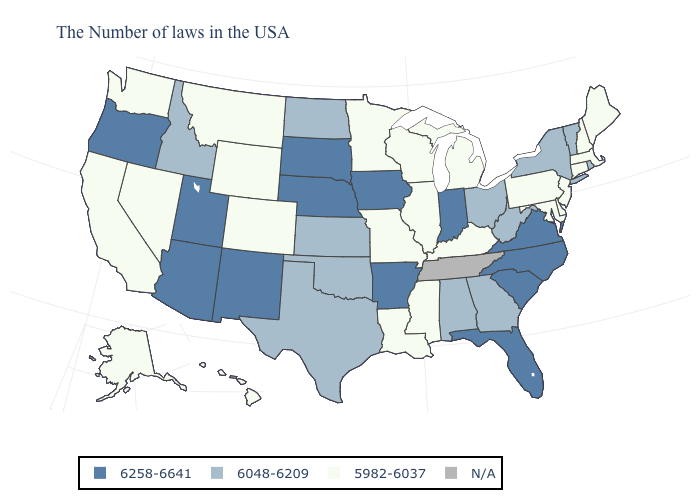Does the map have missing data?
Be succinct. Yes. Is the legend a continuous bar?
Write a very short answer. No. Name the states that have a value in the range 6048-6209?
Quick response, please. Rhode Island, Vermont, New York, West Virginia, Ohio, Georgia, Alabama, Kansas, Oklahoma, Texas, North Dakota, Idaho. What is the value of Nebraska?
Answer briefly. 6258-6641. Name the states that have a value in the range 5982-6037?
Give a very brief answer. Maine, Massachusetts, New Hampshire, Connecticut, New Jersey, Delaware, Maryland, Pennsylvania, Michigan, Kentucky, Wisconsin, Illinois, Mississippi, Louisiana, Missouri, Minnesota, Wyoming, Colorado, Montana, Nevada, California, Washington, Alaska, Hawaii. Which states hav the highest value in the Northeast?
Answer briefly. Rhode Island, Vermont, New York. Does New Mexico have the highest value in the West?
Answer briefly. Yes. What is the highest value in the West ?
Answer briefly. 6258-6641. Name the states that have a value in the range 6258-6641?
Concise answer only. Virginia, North Carolina, South Carolina, Florida, Indiana, Arkansas, Iowa, Nebraska, South Dakota, New Mexico, Utah, Arizona, Oregon. Name the states that have a value in the range 5982-6037?
Concise answer only. Maine, Massachusetts, New Hampshire, Connecticut, New Jersey, Delaware, Maryland, Pennsylvania, Michigan, Kentucky, Wisconsin, Illinois, Mississippi, Louisiana, Missouri, Minnesota, Wyoming, Colorado, Montana, Nevada, California, Washington, Alaska, Hawaii. What is the value of Utah?
Keep it brief. 6258-6641. Among the states that border South Carolina , which have the highest value?
Short answer required. North Carolina. What is the lowest value in states that border Nebraska?
Concise answer only. 5982-6037. Which states have the lowest value in the USA?
Concise answer only. Maine, Massachusetts, New Hampshire, Connecticut, New Jersey, Delaware, Maryland, Pennsylvania, Michigan, Kentucky, Wisconsin, Illinois, Mississippi, Louisiana, Missouri, Minnesota, Wyoming, Colorado, Montana, Nevada, California, Washington, Alaska, Hawaii. Does North Dakota have the highest value in the USA?
Be succinct. No. 